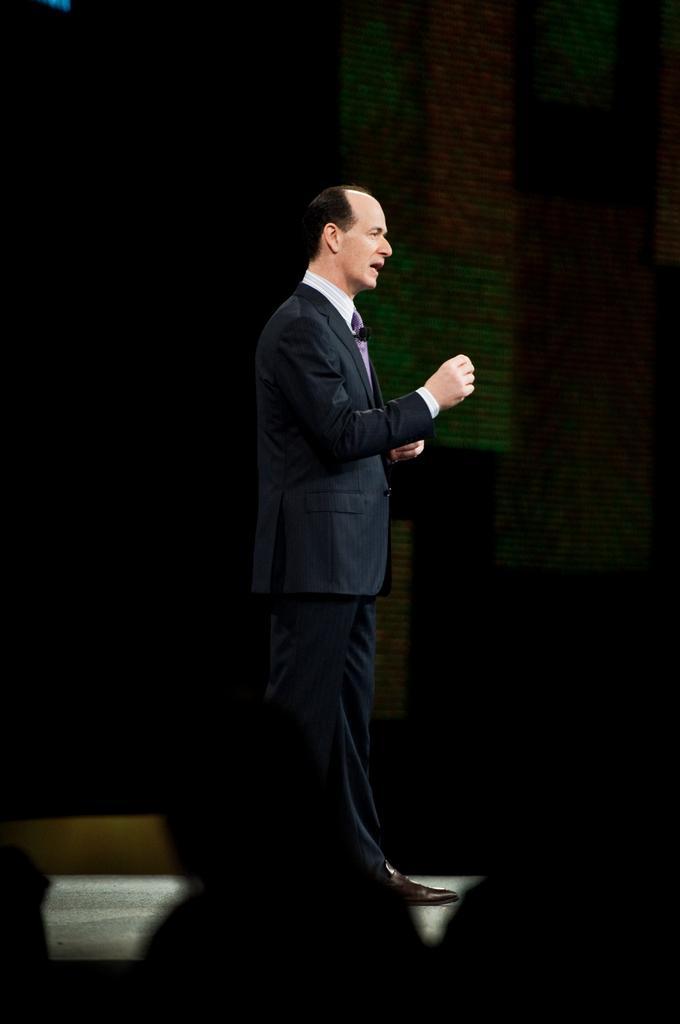In one or two sentences, can you explain what this image depicts? In this image, in the middle, we can see a man standing, he is wearing a coat. There is a dark background. 